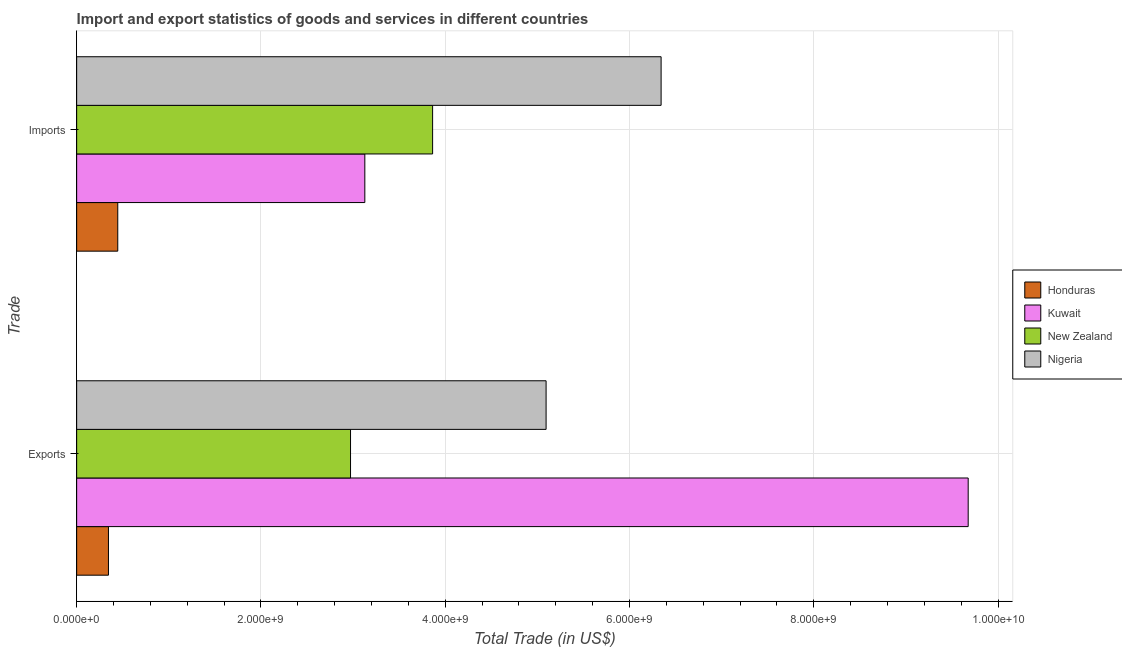How many bars are there on the 1st tick from the top?
Your answer should be very brief. 4. What is the label of the 2nd group of bars from the top?
Ensure brevity in your answer.  Exports. What is the export of goods and services in New Zealand?
Offer a terse response. 2.97e+09. Across all countries, what is the maximum export of goods and services?
Provide a short and direct response. 9.67e+09. Across all countries, what is the minimum export of goods and services?
Ensure brevity in your answer.  3.45e+08. In which country was the imports of goods and services maximum?
Provide a succinct answer. Nigeria. In which country was the export of goods and services minimum?
Give a very brief answer. Honduras. What is the total export of goods and services in the graph?
Ensure brevity in your answer.  1.81e+1. What is the difference between the export of goods and services in Nigeria and that in Kuwait?
Provide a succinct answer. -4.58e+09. What is the difference between the imports of goods and services in Honduras and the export of goods and services in New Zealand?
Your response must be concise. -2.53e+09. What is the average export of goods and services per country?
Your answer should be compact. 4.52e+09. What is the difference between the imports of goods and services and export of goods and services in New Zealand?
Ensure brevity in your answer.  8.91e+08. What is the ratio of the export of goods and services in Nigeria to that in Honduras?
Offer a very short reply. 14.77. Is the imports of goods and services in New Zealand less than that in Nigeria?
Offer a very short reply. Yes. In how many countries, is the export of goods and services greater than the average export of goods and services taken over all countries?
Your answer should be compact. 2. What does the 3rd bar from the top in Exports represents?
Offer a terse response. Kuwait. What does the 3rd bar from the bottom in Imports represents?
Give a very brief answer. New Zealand. How many bars are there?
Provide a short and direct response. 8. What is the difference between two consecutive major ticks on the X-axis?
Provide a short and direct response. 2.00e+09. Does the graph contain any zero values?
Your answer should be very brief. No. What is the title of the graph?
Give a very brief answer. Import and export statistics of goods and services in different countries. What is the label or title of the X-axis?
Offer a terse response. Total Trade (in US$). What is the label or title of the Y-axis?
Your response must be concise. Trade. What is the Total Trade (in US$) of Honduras in Exports?
Your answer should be compact. 3.45e+08. What is the Total Trade (in US$) in Kuwait in Exports?
Provide a short and direct response. 9.67e+09. What is the Total Trade (in US$) of New Zealand in Exports?
Give a very brief answer. 2.97e+09. What is the Total Trade (in US$) of Nigeria in Exports?
Offer a very short reply. 5.09e+09. What is the Total Trade (in US$) in Honduras in Imports?
Keep it short and to the point. 4.46e+08. What is the Total Trade (in US$) in Kuwait in Imports?
Ensure brevity in your answer.  3.13e+09. What is the Total Trade (in US$) of New Zealand in Imports?
Provide a succinct answer. 3.86e+09. What is the Total Trade (in US$) in Nigeria in Imports?
Your response must be concise. 6.34e+09. Across all Trade, what is the maximum Total Trade (in US$) of Honduras?
Ensure brevity in your answer.  4.46e+08. Across all Trade, what is the maximum Total Trade (in US$) of Kuwait?
Provide a succinct answer. 9.67e+09. Across all Trade, what is the maximum Total Trade (in US$) of New Zealand?
Offer a very short reply. 3.86e+09. Across all Trade, what is the maximum Total Trade (in US$) of Nigeria?
Ensure brevity in your answer.  6.34e+09. Across all Trade, what is the minimum Total Trade (in US$) in Honduras?
Your answer should be very brief. 3.45e+08. Across all Trade, what is the minimum Total Trade (in US$) in Kuwait?
Keep it short and to the point. 3.13e+09. Across all Trade, what is the minimum Total Trade (in US$) of New Zealand?
Make the answer very short. 2.97e+09. Across all Trade, what is the minimum Total Trade (in US$) of Nigeria?
Make the answer very short. 5.09e+09. What is the total Total Trade (in US$) in Honduras in the graph?
Offer a very short reply. 7.91e+08. What is the total Total Trade (in US$) in Kuwait in the graph?
Make the answer very short. 1.28e+1. What is the total Total Trade (in US$) in New Zealand in the graph?
Ensure brevity in your answer.  6.83e+09. What is the total Total Trade (in US$) of Nigeria in the graph?
Offer a terse response. 1.14e+1. What is the difference between the Total Trade (in US$) in Honduras in Exports and that in Imports?
Ensure brevity in your answer.  -1.01e+08. What is the difference between the Total Trade (in US$) of Kuwait in Exports and that in Imports?
Your answer should be very brief. 6.55e+09. What is the difference between the Total Trade (in US$) in New Zealand in Exports and that in Imports?
Give a very brief answer. -8.91e+08. What is the difference between the Total Trade (in US$) in Nigeria in Exports and that in Imports?
Ensure brevity in your answer.  -1.25e+09. What is the difference between the Total Trade (in US$) of Honduras in Exports and the Total Trade (in US$) of Kuwait in Imports?
Your response must be concise. -2.78e+09. What is the difference between the Total Trade (in US$) of Honduras in Exports and the Total Trade (in US$) of New Zealand in Imports?
Ensure brevity in your answer.  -3.52e+09. What is the difference between the Total Trade (in US$) of Honduras in Exports and the Total Trade (in US$) of Nigeria in Imports?
Provide a succinct answer. -6.00e+09. What is the difference between the Total Trade (in US$) of Kuwait in Exports and the Total Trade (in US$) of New Zealand in Imports?
Keep it short and to the point. 5.81e+09. What is the difference between the Total Trade (in US$) of Kuwait in Exports and the Total Trade (in US$) of Nigeria in Imports?
Offer a very short reply. 3.33e+09. What is the difference between the Total Trade (in US$) of New Zealand in Exports and the Total Trade (in US$) of Nigeria in Imports?
Keep it short and to the point. -3.37e+09. What is the average Total Trade (in US$) of Honduras per Trade?
Make the answer very short. 3.96e+08. What is the average Total Trade (in US$) in Kuwait per Trade?
Your response must be concise. 6.40e+09. What is the average Total Trade (in US$) of New Zealand per Trade?
Ensure brevity in your answer.  3.42e+09. What is the average Total Trade (in US$) of Nigeria per Trade?
Provide a succinct answer. 5.72e+09. What is the difference between the Total Trade (in US$) of Honduras and Total Trade (in US$) of Kuwait in Exports?
Provide a short and direct response. -9.33e+09. What is the difference between the Total Trade (in US$) of Honduras and Total Trade (in US$) of New Zealand in Exports?
Make the answer very short. -2.63e+09. What is the difference between the Total Trade (in US$) in Honduras and Total Trade (in US$) in Nigeria in Exports?
Keep it short and to the point. -4.75e+09. What is the difference between the Total Trade (in US$) in Kuwait and Total Trade (in US$) in New Zealand in Exports?
Your answer should be compact. 6.70e+09. What is the difference between the Total Trade (in US$) in Kuwait and Total Trade (in US$) in Nigeria in Exports?
Keep it short and to the point. 4.58e+09. What is the difference between the Total Trade (in US$) in New Zealand and Total Trade (in US$) in Nigeria in Exports?
Keep it short and to the point. -2.12e+09. What is the difference between the Total Trade (in US$) of Honduras and Total Trade (in US$) of Kuwait in Imports?
Ensure brevity in your answer.  -2.68e+09. What is the difference between the Total Trade (in US$) of Honduras and Total Trade (in US$) of New Zealand in Imports?
Give a very brief answer. -3.42e+09. What is the difference between the Total Trade (in US$) in Honduras and Total Trade (in US$) in Nigeria in Imports?
Keep it short and to the point. -5.90e+09. What is the difference between the Total Trade (in US$) in Kuwait and Total Trade (in US$) in New Zealand in Imports?
Offer a very short reply. -7.36e+08. What is the difference between the Total Trade (in US$) in Kuwait and Total Trade (in US$) in Nigeria in Imports?
Make the answer very short. -3.22e+09. What is the difference between the Total Trade (in US$) of New Zealand and Total Trade (in US$) of Nigeria in Imports?
Make the answer very short. -2.48e+09. What is the ratio of the Total Trade (in US$) in Honduras in Exports to that in Imports?
Provide a succinct answer. 0.77. What is the ratio of the Total Trade (in US$) of Kuwait in Exports to that in Imports?
Make the answer very short. 3.09. What is the ratio of the Total Trade (in US$) of New Zealand in Exports to that in Imports?
Give a very brief answer. 0.77. What is the ratio of the Total Trade (in US$) in Nigeria in Exports to that in Imports?
Your answer should be compact. 0.8. What is the difference between the highest and the second highest Total Trade (in US$) in Honduras?
Provide a succinct answer. 1.01e+08. What is the difference between the highest and the second highest Total Trade (in US$) of Kuwait?
Make the answer very short. 6.55e+09. What is the difference between the highest and the second highest Total Trade (in US$) in New Zealand?
Provide a succinct answer. 8.91e+08. What is the difference between the highest and the second highest Total Trade (in US$) in Nigeria?
Make the answer very short. 1.25e+09. What is the difference between the highest and the lowest Total Trade (in US$) of Honduras?
Ensure brevity in your answer.  1.01e+08. What is the difference between the highest and the lowest Total Trade (in US$) in Kuwait?
Your answer should be very brief. 6.55e+09. What is the difference between the highest and the lowest Total Trade (in US$) in New Zealand?
Your response must be concise. 8.91e+08. What is the difference between the highest and the lowest Total Trade (in US$) of Nigeria?
Offer a terse response. 1.25e+09. 